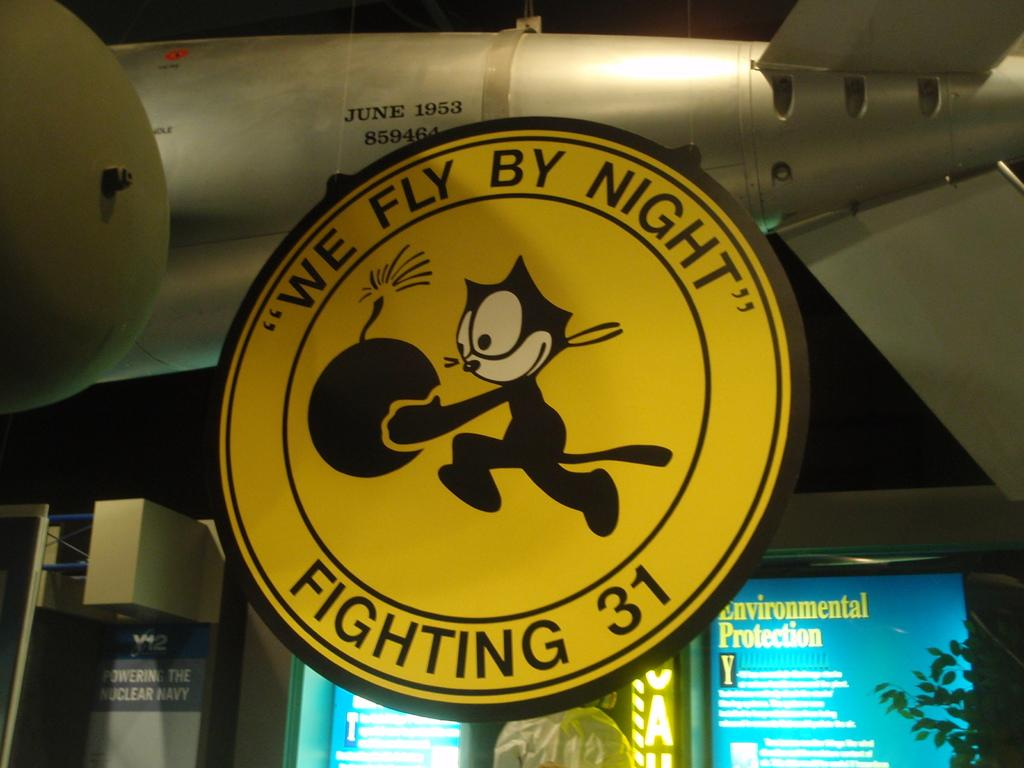<image>
Create a compact narrative representing the image presented. A yellow sign hanging from a tiny airplane that says "We Fly By Night" Fighting 31 